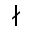<formula> <loc_0><loc_0><loc_500><loc_500>\nmid</formula> 